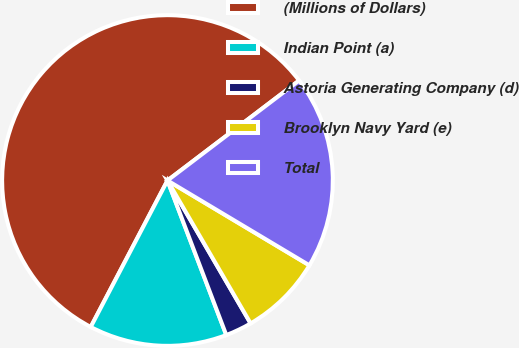Convert chart to OTSL. <chart><loc_0><loc_0><loc_500><loc_500><pie_chart><fcel>(Millions of Dollars)<fcel>Indian Point (a)<fcel>Astoria Generating Company (d)<fcel>Brooklyn Navy Yard (e)<fcel>Total<nl><fcel>56.98%<fcel>13.47%<fcel>2.6%<fcel>8.04%<fcel>18.91%<nl></chart> 